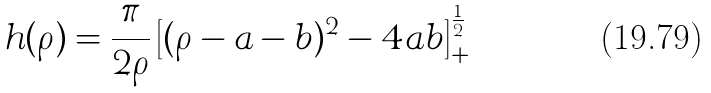Convert formula to latex. <formula><loc_0><loc_0><loc_500><loc_500>h ( \rho ) = \frac { \pi } { 2 \rho } \left [ ( \rho - a - b ) ^ { 2 } - 4 a b \right ] _ { + } ^ { \frac { 1 } { 2 } }</formula> 